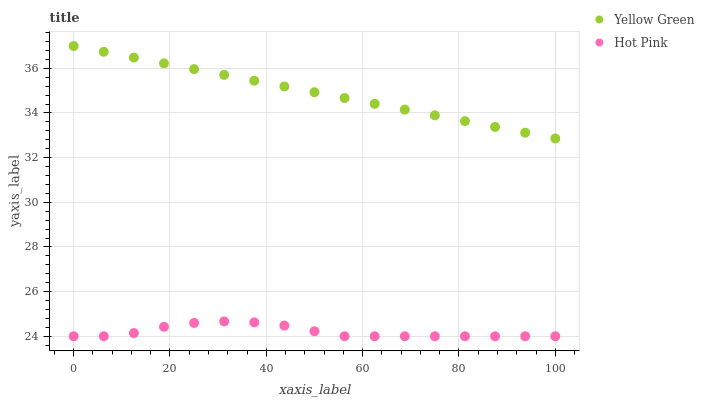Does Hot Pink have the minimum area under the curve?
Answer yes or no. Yes. Does Yellow Green have the maximum area under the curve?
Answer yes or no. Yes. Does Yellow Green have the minimum area under the curve?
Answer yes or no. No. Is Yellow Green the smoothest?
Answer yes or no. Yes. Is Hot Pink the roughest?
Answer yes or no. Yes. Is Yellow Green the roughest?
Answer yes or no. No. Does Hot Pink have the lowest value?
Answer yes or no. Yes. Does Yellow Green have the lowest value?
Answer yes or no. No. Does Yellow Green have the highest value?
Answer yes or no. Yes. Is Hot Pink less than Yellow Green?
Answer yes or no. Yes. Is Yellow Green greater than Hot Pink?
Answer yes or no. Yes. Does Hot Pink intersect Yellow Green?
Answer yes or no. No. 